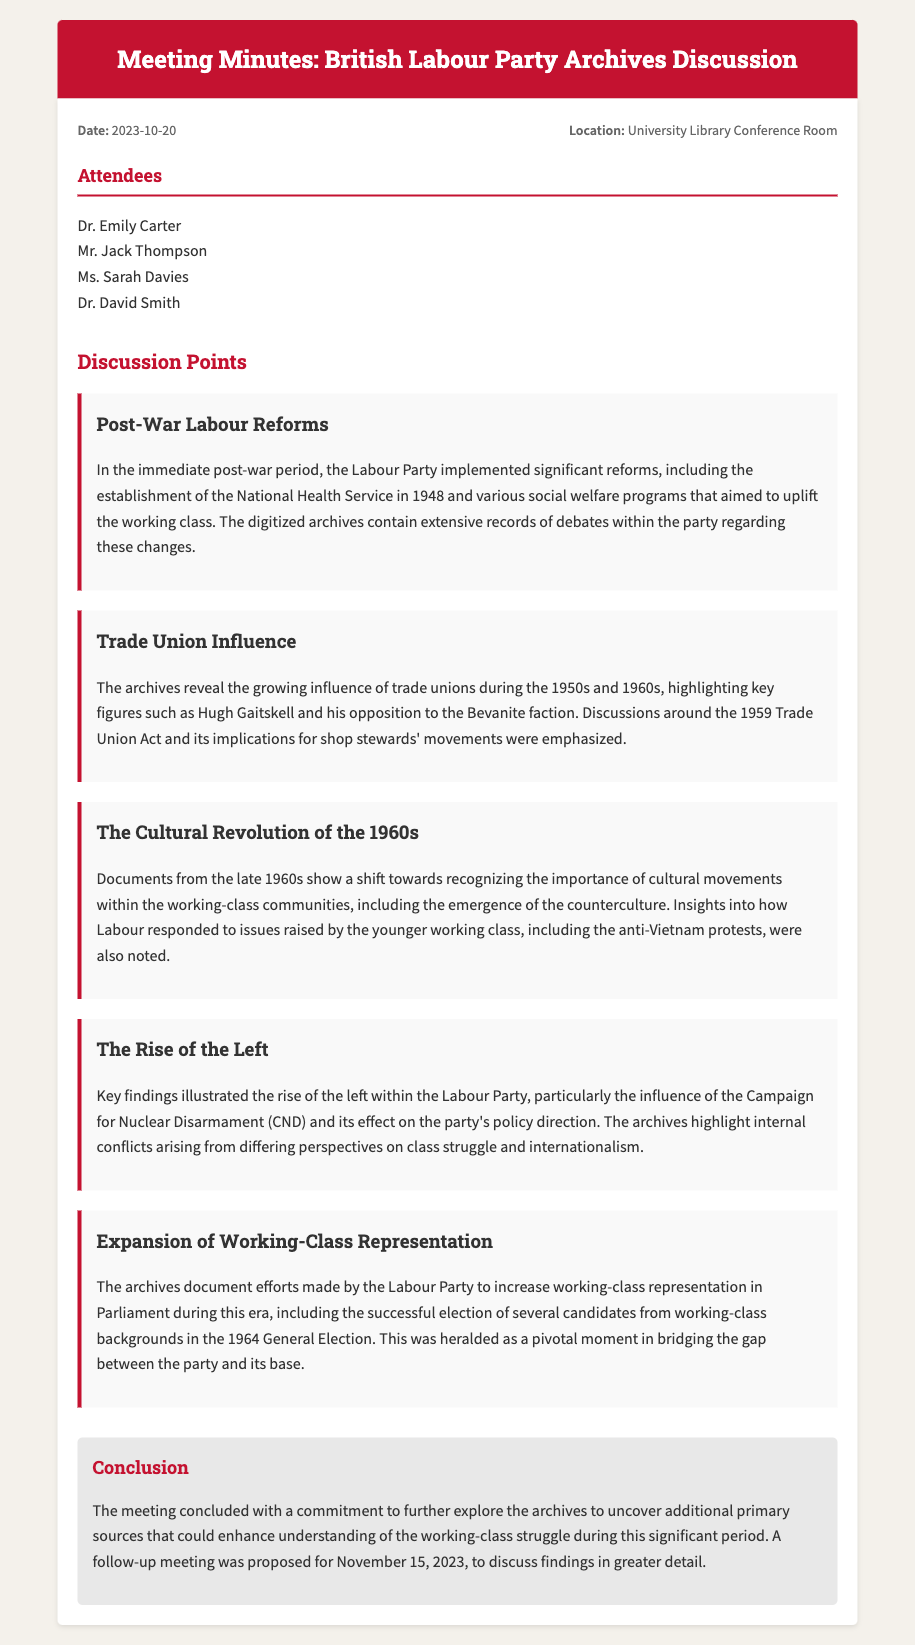What is the date of the meeting? The date of the meeting is mentioned in the meta section of the document.
Answer: 2023-10-20 Where was the meeting held? The location of the meeting is provided in the meta section of the document.
Answer: University Library Conference Room Who is one of the attendees? Attendees are listed in the document, and any name can be used as an answer.
Answer: Dr. Emily Carter What significant reform was established in 1948? The discussion point talks about the establishment of the National Health Service in 1948.
Answer: National Health Service What was a key focus of the 1959 Trade Union Act? The discussion mentions the implications for shop stewards' movements as a focus of the 1959 Trade Union Act.
Answer: Shop stewards' movements Which cultural phenomenon is noted in the 1960s discussion? The discussion points highlight the emergence of the counterculture within the working-class communities.
Answer: Counterculture What was recognized as a pivotal moment for working-class representation? The archives note the successful election of several candidates from working-class backgrounds during the 1964 General Election as a pivotal moment.
Answer: 1964 General Election What was a key finding regarding the rise of the left? The archives illustrated the influence of the Campaign for Nuclear Disarmament on the party's policy direction.
Answer: Campaign for Nuclear Disarmament When is the follow-up meeting proposed? The conclusion section of the document specifies the date for the follow-up meeting.
Answer: November 15, 2023 